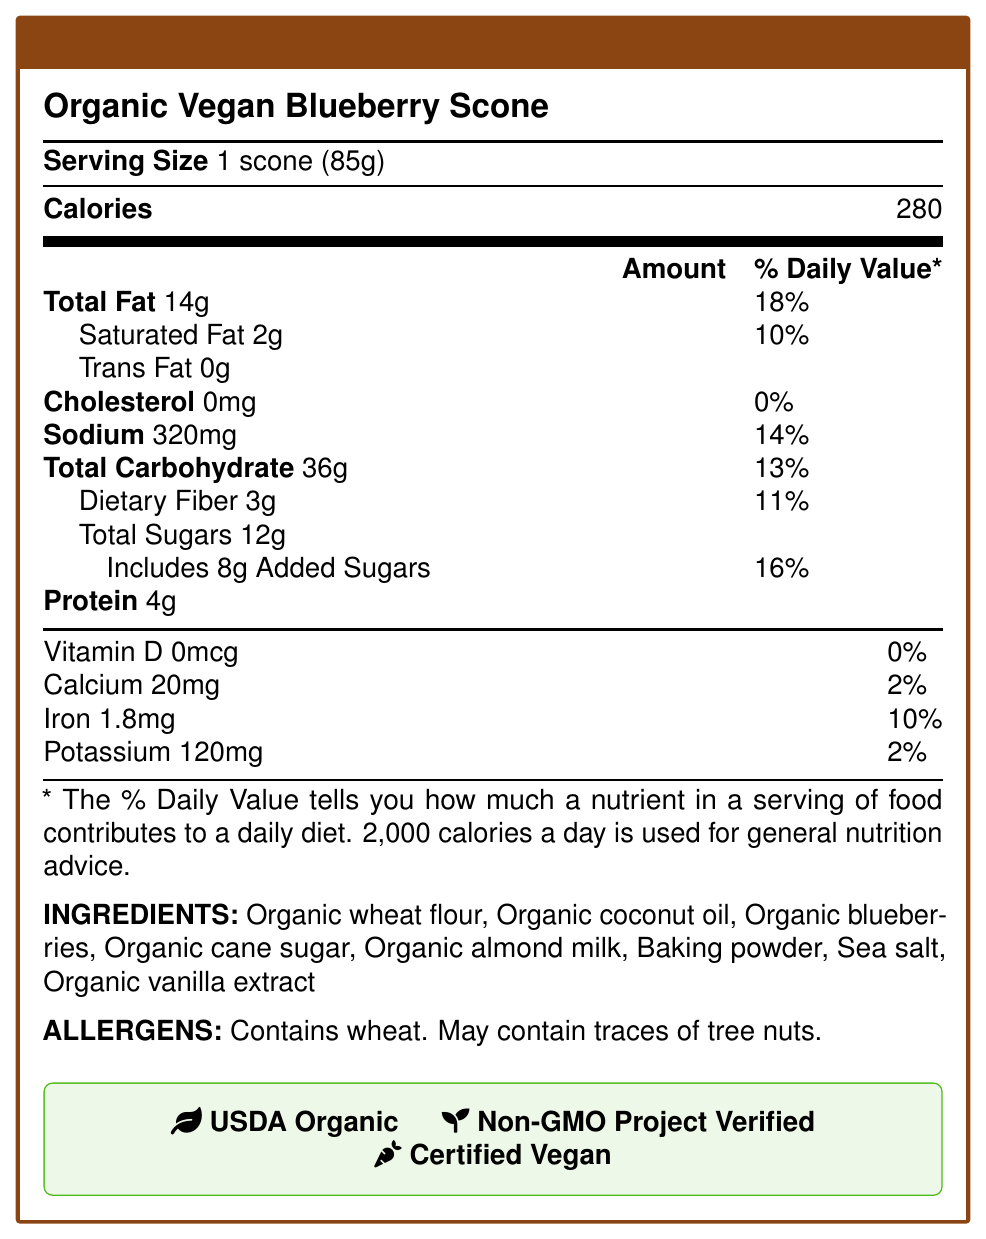what is the serving size of the Organic Vegan Blueberry Scone? The serving size is mentioned right after the product name and is specified as 1 scone weighing 85 grams.
Answer: 1 scone (85g) how many calories are in one serving? The number of calories per serving is listed directly below the serving size and serving per container information.
Answer: 280 what is the total carbohydrate content per serving? The total carbohydrate content is clearly listed in the nutrition facts under "Total Carbohydrate."
Answer: 36g what percentage of the daily value for iron does one scone provide? The percentage of the daily value for iron is listed in the section beneath the total macronutrients, under the vitamins and minerals.
Answer: 10% what allergens are present in this product? The allergen information is listed towards the end of the document.
Answer: Contains wheat, May contain traces of tree nuts. what is the percentage of the daily value for saturated fat in one serving? The percentage daily value for saturated fat is found right next to its amount under the "Total Fat" section.
Answer: 10% which ingredient is not organic? All other ingredients listed are marked as organic, except for baking powder and sea salt.
Answer: Baking powder, Sea salt how much added sugar is in one serving? The amount of added sugar is specified under the "Total Sugars" section.
Answer: 8g which vitamin is entirely absent in the scone? The document states "Vitamin D 0mcg" with 0% daily value contribution.
Answer: Vitamin D identify the certification that verifies the product as organic. A. USDA Organic B. Non-GMO Project Verified C. Certified Vegan The USDA Organic certification is the one that specifically verifies organic status.
Answer: A what is the sodium content per serving? A. 320mg B. 120mg C. 20mg The sodium content per serving is listed as 320mg.
Answer: A is the product compliant with FDA labeling requirements for vegan and organic products? The legal considerations section mentions that the product complies with FDA labeling requirements for vegan and organic products.
Answer: Yes is the product gluten-free? The product contains wheat, as mentioned in the allergen statement, so it is not gluten-free.
Answer: No summarize the main information provided in the document. The document highlights the nutritional break-down per serving, lists ingredients, mentions potential allergens, and shows certifications such as USDA Organic, Non-GMO Project Verified, and Certified Vegan. Legal compliance details are also provided.
Answer: The document is a Nutrition Facts Label for an Organic Vegan Blueberry Scone, providing detailed nutritional content, ingredient list, allergen information, and various certifications. It notes compliance with FDA requirements and other legal considerations. who is the manufacturer of the scone? The document does not provide any information regarding the manufacturer of the scone.
Answer: Cannot be determined what certifications does the product have? The certifications are listed in a green box towards the bottom of the main content area.
Answer: USDA Organic, Non-GMO Project Verified, Certified Vegan 